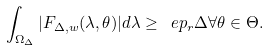Convert formula to latex. <formula><loc_0><loc_0><loc_500><loc_500>\int _ { \Omega _ { \Delta } } | F _ { \Delta , w } ( \lambda , \theta ) | d \lambda \geq \ e p _ { r } \Delta \forall \theta \in \Theta .</formula> 